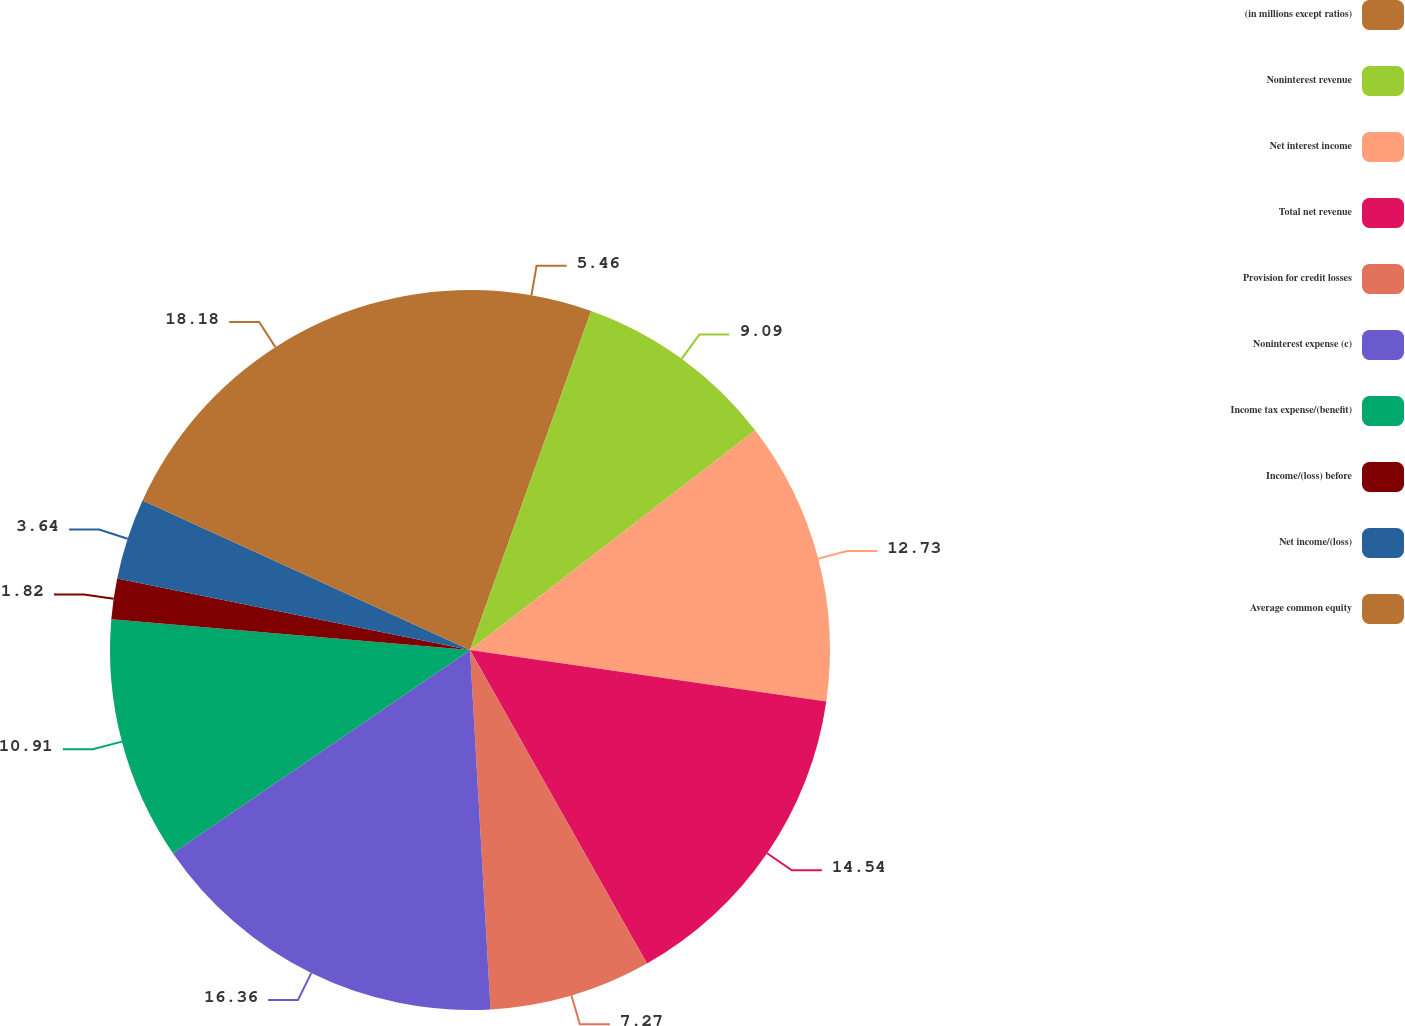<chart> <loc_0><loc_0><loc_500><loc_500><pie_chart><fcel>(in millions except ratios)<fcel>Noninterest revenue<fcel>Net interest income<fcel>Total net revenue<fcel>Provision for credit losses<fcel>Noninterest expense (c)<fcel>Income tax expense/(benefit)<fcel>Income/(loss) before<fcel>Net income/(loss)<fcel>Average common equity<nl><fcel>5.46%<fcel>9.09%<fcel>12.73%<fcel>14.54%<fcel>7.27%<fcel>16.36%<fcel>10.91%<fcel>1.82%<fcel>3.64%<fcel>18.18%<nl></chart> 